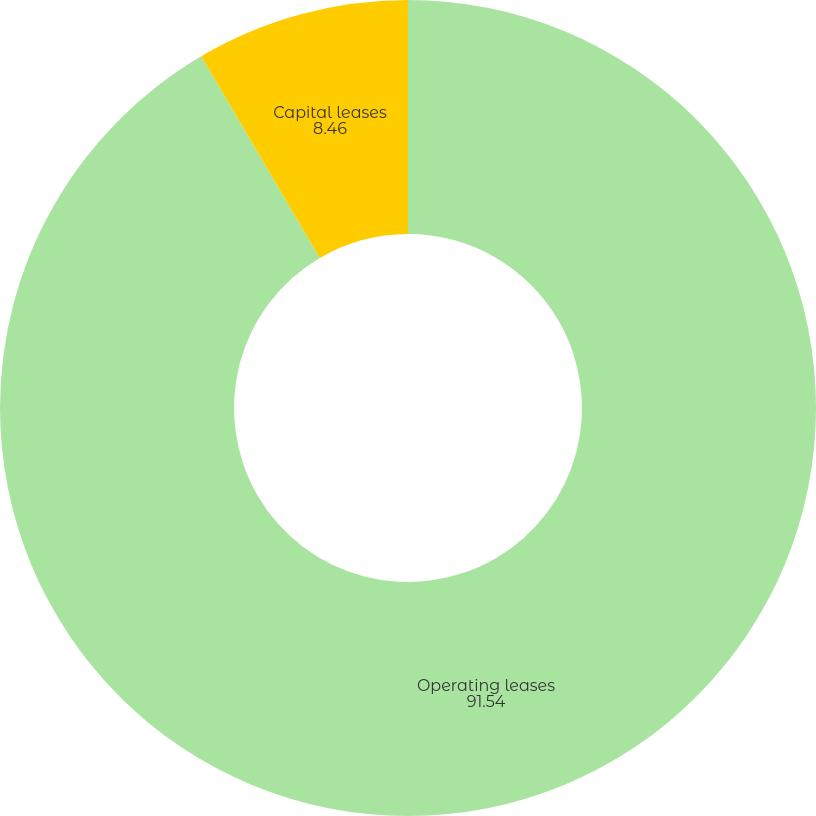Convert chart. <chart><loc_0><loc_0><loc_500><loc_500><pie_chart><fcel>Operating leases<fcel>Capital leases<nl><fcel>91.54%<fcel>8.46%<nl></chart> 